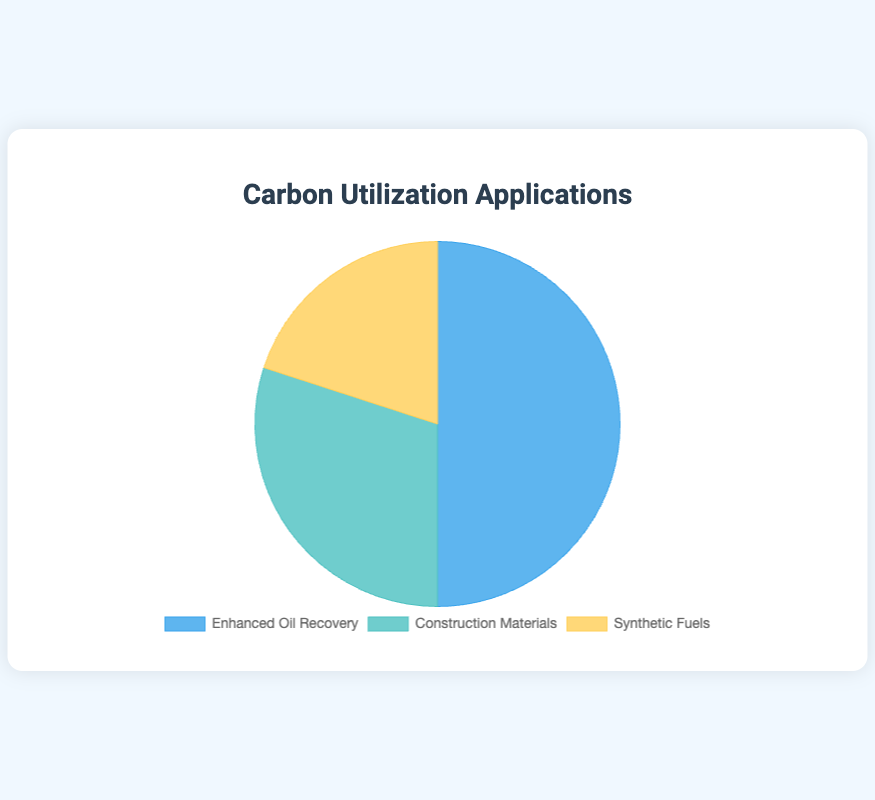What percentage of carbon utilization goes into synthetic fuels? The pie chart shows that synthetic fuels take up 20% of the carbon utilization applications. We can see this by looking at the labeled segment of the pie chart.
Answer: 20% Which carbon utilization application is the largest? The pie chart displays three segments each representing one application. The largest segment corresponds to Enhanced Oil Recovery which takes up 50% of the chart.
Answer: Enhanced Oil Recovery Is the percentage of carbon utilized for Enhanced Oil Recovery greater than the sum of the other two applications? Adding the percentages for Construction Materials and Synthetic Fuels, we get 30% + 20% = 50%. Comparing this sum to the percentage for Enhanced Oil Recovery, which is also 50%, we see that they are equal.
Answer: No By how much does the percentage of carbon utilization in Enhanced Oil Recovery exceed that of Construction Materials? Comparing the segments, Enhanced Oil Recovery is 50% and Construction Materials is 30%. To determine the excess, we subtract 30% from 50% which gives us 20%.
Answer: 20% What combined percentage of carbon utilization is dedicated to applications other than Enhanced Oil Recovery? The pie chart shows the percentages of each application, and excluding Enhanced Oil Recovery, we have Construction Materials (30%) and Synthetic Fuels (20%). Adding these, 30% + 20% = 50%.
Answer: 50% Which application is represented by the blue segment in the pie chart? Visually, the segment corresponding to Enhanced Oil Recovery is colored blue in the pie chart.
Answer: Enhanced Oil Recovery What is the difference in percentage points between the highest and lowest carbon utilization applications? From the pie chart, Enhanced Oil Recovery is 50%, and Synthetic Fuels is 20%. The difference is calculated as 50% - 20% = 30%.
Answer: 30% Are the percentages of Construction Materials and Synthetic Fuels combined greater than that of Enhanced Oil Recovery? Adding Construction Materials (30%) and Synthetic Fuels (20%) gives 50%, which is equal to Enhanced Oil Recovery (50%). Therefore, they are not greater.
Answer: No 